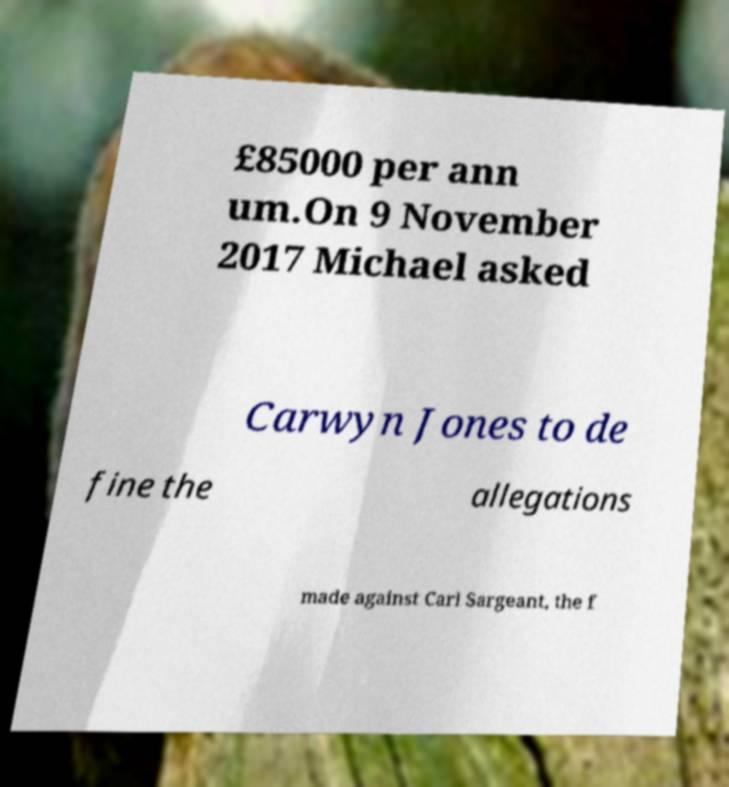For documentation purposes, I need the text within this image transcribed. Could you provide that? £85000 per ann um.On 9 November 2017 Michael asked Carwyn Jones to de fine the allegations made against Carl Sargeant, the f 